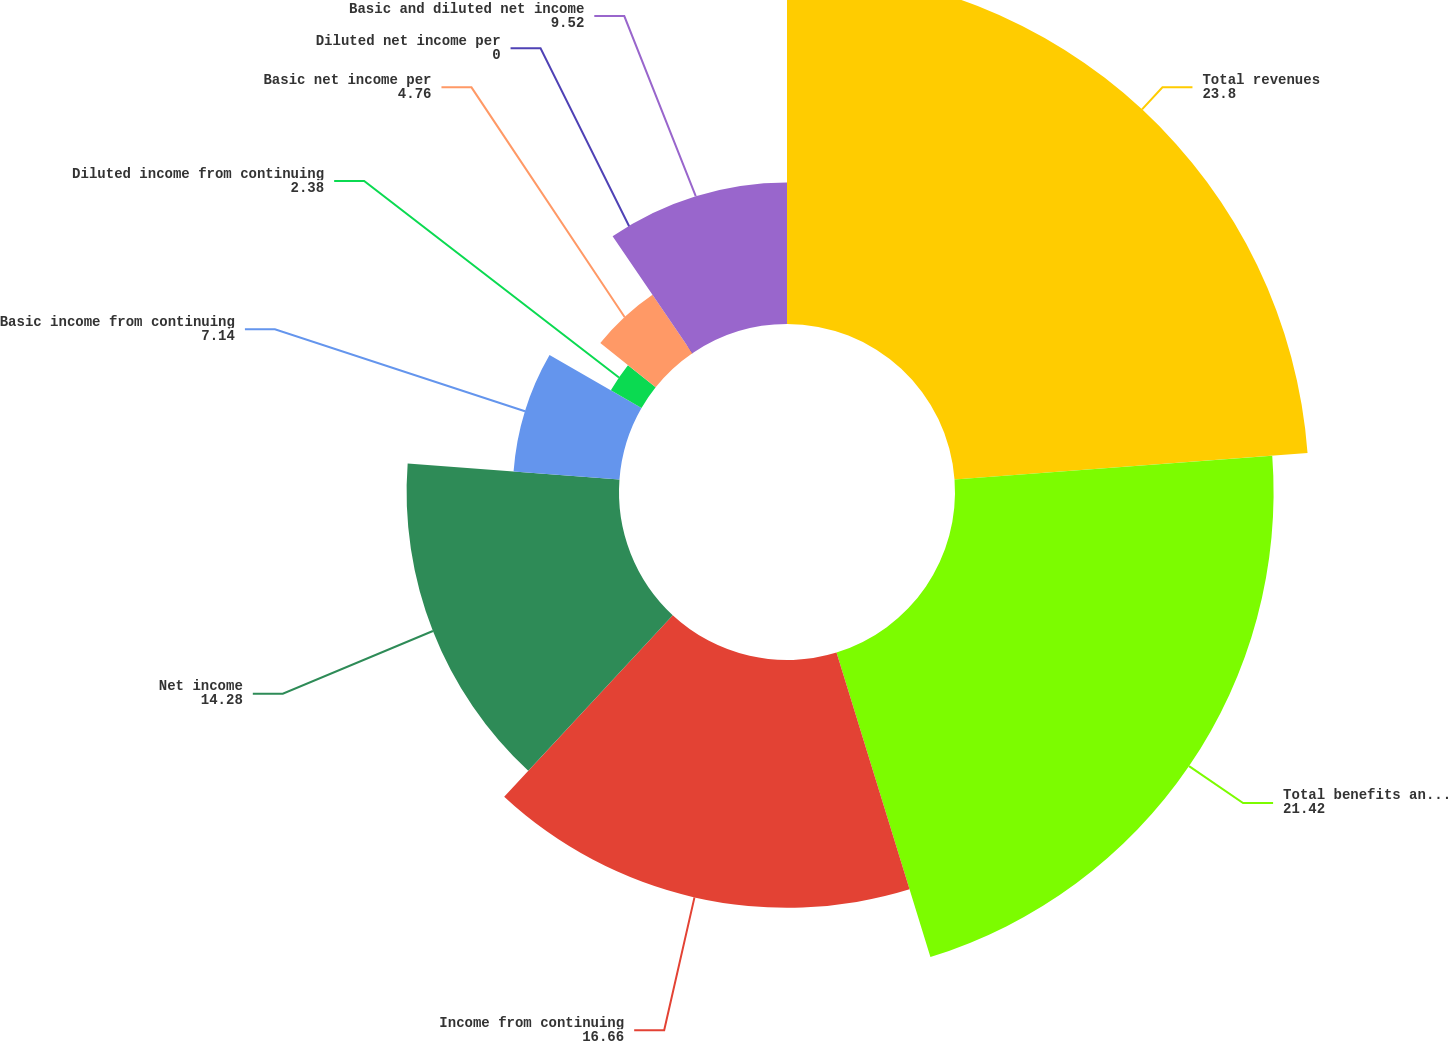<chart> <loc_0><loc_0><loc_500><loc_500><pie_chart><fcel>Total revenues<fcel>Total benefits and expenses<fcel>Income from continuing<fcel>Net income<fcel>Basic income from continuing<fcel>Diluted income from continuing<fcel>Basic net income per<fcel>Diluted net income per<fcel>Basic and diluted net income<nl><fcel>23.8%<fcel>21.42%<fcel>16.66%<fcel>14.28%<fcel>7.14%<fcel>2.38%<fcel>4.76%<fcel>0.0%<fcel>9.52%<nl></chart> 